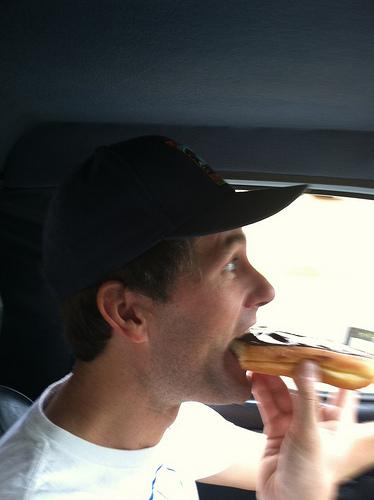Question: what side of the man is this picture taken of?
Choices:
A. Left.
B. Front.
C. Back.
D. Right.
Answer with the letter. Answer: D Question: who is driving?
Choices:
A. A woman.
B. A teenager.
C. A man.
D. An old lady.
Answer with the letter. Answer: C Question: where was this picture taken?
Choices:
A. A bus.
B. A car.
C. A truck.
D. A taxi.
Answer with the letter. Answer: B Question: what hand is the man using to eat?
Choices:
A. Left.
B. Right.
C. The man next to him's.
D. His wife's.
Answer with the letter. Answer: B 